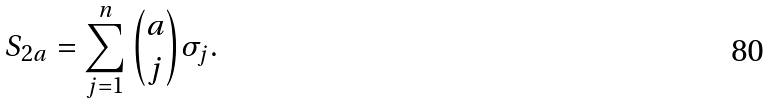Convert formula to latex. <formula><loc_0><loc_0><loc_500><loc_500>S _ { 2 a } = \sum _ { j = 1 } ^ { n } \binom { a } { j } \sigma _ { j } .</formula> 